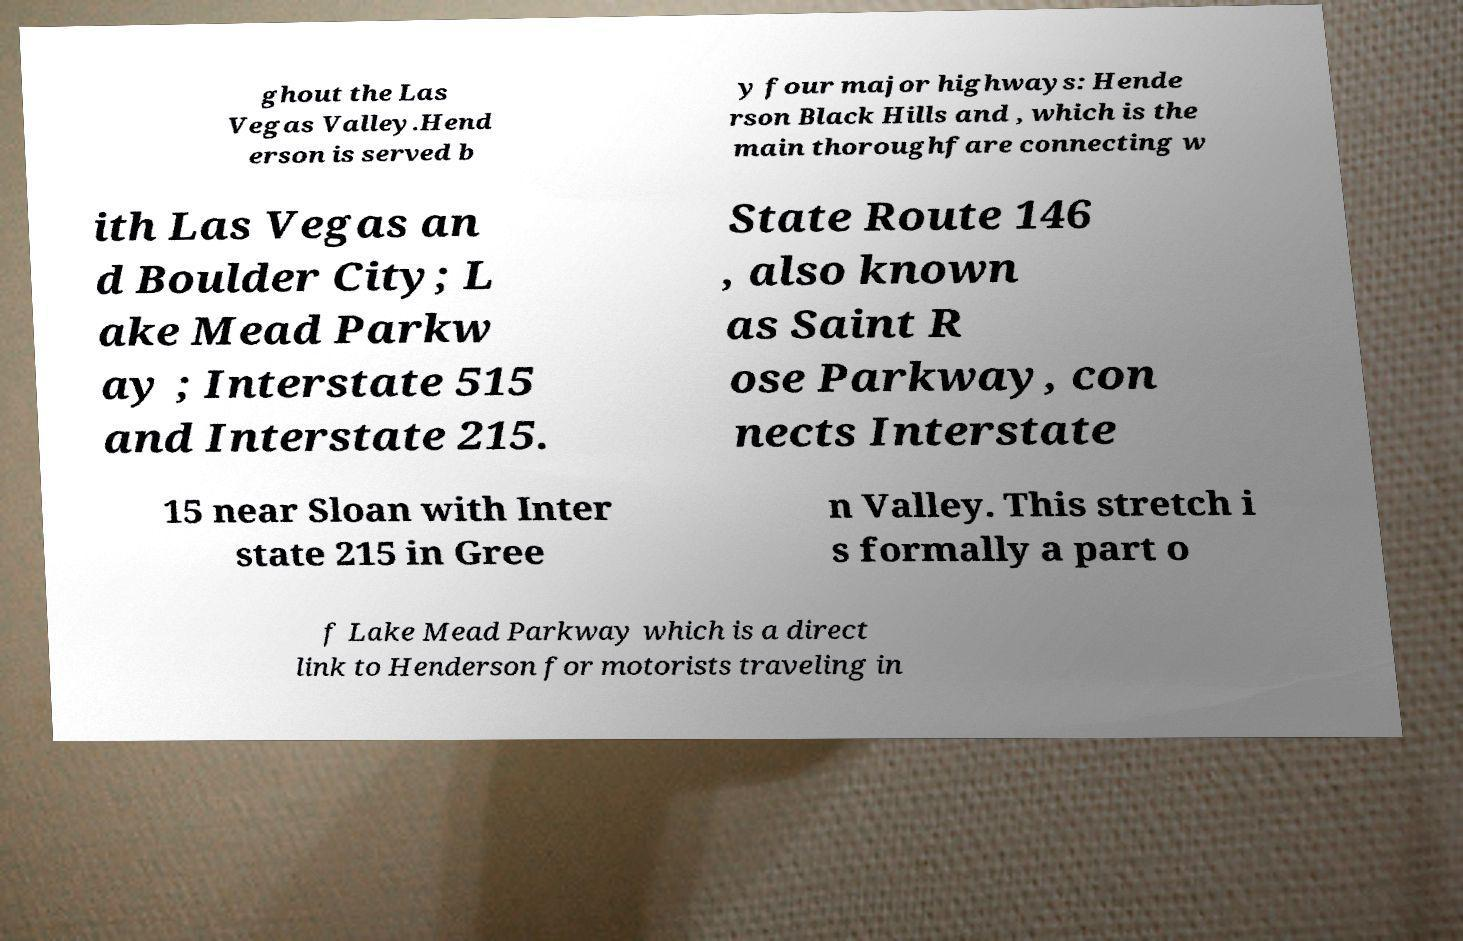There's text embedded in this image that I need extracted. Can you transcribe it verbatim? ghout the Las Vegas Valley.Hend erson is served b y four major highways: Hende rson Black Hills and , which is the main thoroughfare connecting w ith Las Vegas an d Boulder City; L ake Mead Parkw ay ; Interstate 515 and Interstate 215. State Route 146 , also known as Saint R ose Parkway, con nects Interstate 15 near Sloan with Inter state 215 in Gree n Valley. This stretch i s formally a part o f Lake Mead Parkway which is a direct link to Henderson for motorists traveling in 